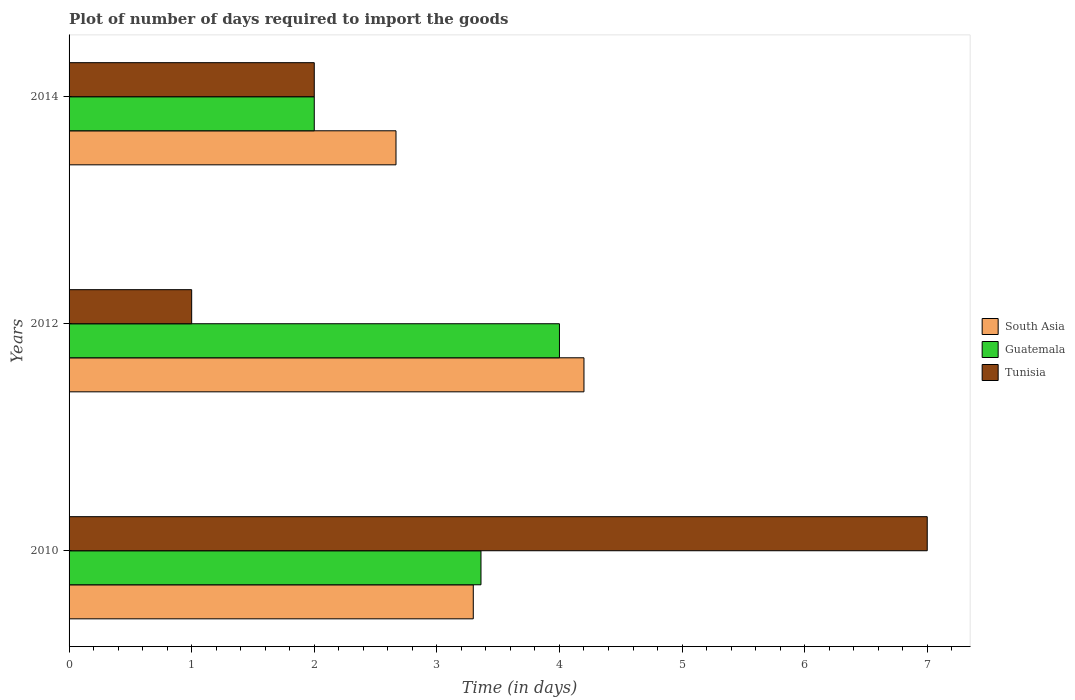How many groups of bars are there?
Make the answer very short. 3. Are the number of bars per tick equal to the number of legend labels?
Your response must be concise. Yes. Are the number of bars on each tick of the Y-axis equal?
Ensure brevity in your answer.  Yes. How many bars are there on the 1st tick from the top?
Make the answer very short. 3. How many bars are there on the 1st tick from the bottom?
Give a very brief answer. 3. What is the label of the 3rd group of bars from the top?
Ensure brevity in your answer.  2010. What is the time required to import goods in South Asia in 2014?
Keep it short and to the point. 2.67. Across all years, what is the maximum time required to import goods in Guatemala?
Your answer should be very brief. 4. Across all years, what is the minimum time required to import goods in Guatemala?
Provide a short and direct response. 2. In which year was the time required to import goods in South Asia minimum?
Provide a succinct answer. 2014. What is the total time required to import goods in Tunisia in the graph?
Your answer should be very brief. 10. What is the difference between the time required to import goods in Tunisia in 2010 and that in 2014?
Keep it short and to the point. 5. What is the difference between the time required to import goods in Guatemala in 2010 and the time required to import goods in Tunisia in 2012?
Give a very brief answer. 2.36. What is the average time required to import goods in Tunisia per year?
Provide a succinct answer. 3.33. In the year 2012, what is the difference between the time required to import goods in Tunisia and time required to import goods in South Asia?
Keep it short and to the point. -3.2. What is the ratio of the time required to import goods in Guatemala in 2010 to that in 2012?
Provide a succinct answer. 0.84. What is the difference between the highest and the second highest time required to import goods in Guatemala?
Provide a succinct answer. 0.64. In how many years, is the time required to import goods in Tunisia greater than the average time required to import goods in Tunisia taken over all years?
Your answer should be compact. 1. What does the 2nd bar from the top in 2014 represents?
Give a very brief answer. Guatemala. Are all the bars in the graph horizontal?
Your answer should be compact. Yes. How many years are there in the graph?
Keep it short and to the point. 3. What is the difference between two consecutive major ticks on the X-axis?
Provide a succinct answer. 1. Are the values on the major ticks of X-axis written in scientific E-notation?
Offer a very short reply. No. Does the graph contain grids?
Offer a terse response. No. Where does the legend appear in the graph?
Offer a terse response. Center right. How are the legend labels stacked?
Provide a short and direct response. Vertical. What is the title of the graph?
Provide a succinct answer. Plot of number of days required to import the goods. What is the label or title of the X-axis?
Give a very brief answer. Time (in days). What is the Time (in days) of South Asia in 2010?
Make the answer very short. 3.3. What is the Time (in days) of Guatemala in 2010?
Make the answer very short. 3.36. What is the Time (in days) in Guatemala in 2012?
Offer a terse response. 4. What is the Time (in days) of Tunisia in 2012?
Offer a very short reply. 1. What is the Time (in days) of South Asia in 2014?
Provide a short and direct response. 2.67. What is the Time (in days) of Guatemala in 2014?
Offer a terse response. 2. Across all years, what is the maximum Time (in days) in Guatemala?
Keep it short and to the point. 4. Across all years, what is the minimum Time (in days) of South Asia?
Provide a succinct answer. 2.67. Across all years, what is the minimum Time (in days) of Tunisia?
Make the answer very short. 1. What is the total Time (in days) in South Asia in the graph?
Offer a very short reply. 10.16. What is the total Time (in days) in Guatemala in the graph?
Ensure brevity in your answer.  9.36. What is the difference between the Time (in days) in South Asia in 2010 and that in 2012?
Make the answer very short. -0.9. What is the difference between the Time (in days) of Guatemala in 2010 and that in 2012?
Keep it short and to the point. -0.64. What is the difference between the Time (in days) of South Asia in 2010 and that in 2014?
Ensure brevity in your answer.  0.63. What is the difference between the Time (in days) of Guatemala in 2010 and that in 2014?
Provide a short and direct response. 1.36. What is the difference between the Time (in days) of Tunisia in 2010 and that in 2014?
Your response must be concise. 5. What is the difference between the Time (in days) of South Asia in 2012 and that in 2014?
Provide a succinct answer. 1.53. What is the difference between the Time (in days) in South Asia in 2010 and the Time (in days) in Guatemala in 2012?
Offer a terse response. -0.7. What is the difference between the Time (in days) of South Asia in 2010 and the Time (in days) of Tunisia in 2012?
Ensure brevity in your answer.  2.3. What is the difference between the Time (in days) in Guatemala in 2010 and the Time (in days) in Tunisia in 2012?
Keep it short and to the point. 2.36. What is the difference between the Time (in days) of South Asia in 2010 and the Time (in days) of Guatemala in 2014?
Ensure brevity in your answer.  1.3. What is the difference between the Time (in days) in South Asia in 2010 and the Time (in days) in Tunisia in 2014?
Provide a succinct answer. 1.3. What is the difference between the Time (in days) in Guatemala in 2010 and the Time (in days) in Tunisia in 2014?
Your answer should be compact. 1.36. What is the average Time (in days) in South Asia per year?
Keep it short and to the point. 3.39. What is the average Time (in days) in Guatemala per year?
Keep it short and to the point. 3.12. In the year 2010, what is the difference between the Time (in days) of South Asia and Time (in days) of Guatemala?
Provide a succinct answer. -0.06. In the year 2010, what is the difference between the Time (in days) of South Asia and Time (in days) of Tunisia?
Your response must be concise. -3.7. In the year 2010, what is the difference between the Time (in days) of Guatemala and Time (in days) of Tunisia?
Give a very brief answer. -3.64. In the year 2012, what is the difference between the Time (in days) of South Asia and Time (in days) of Tunisia?
Give a very brief answer. 3.2. In the year 2012, what is the difference between the Time (in days) of Guatemala and Time (in days) of Tunisia?
Give a very brief answer. 3. In the year 2014, what is the difference between the Time (in days) of South Asia and Time (in days) of Guatemala?
Your response must be concise. 0.67. What is the ratio of the Time (in days) of South Asia in 2010 to that in 2012?
Provide a short and direct response. 0.79. What is the ratio of the Time (in days) in Guatemala in 2010 to that in 2012?
Give a very brief answer. 0.84. What is the ratio of the Time (in days) of Tunisia in 2010 to that in 2012?
Provide a succinct answer. 7. What is the ratio of the Time (in days) of South Asia in 2010 to that in 2014?
Give a very brief answer. 1.24. What is the ratio of the Time (in days) of Guatemala in 2010 to that in 2014?
Provide a short and direct response. 1.68. What is the ratio of the Time (in days) of Tunisia in 2010 to that in 2014?
Your answer should be very brief. 3.5. What is the ratio of the Time (in days) of South Asia in 2012 to that in 2014?
Offer a very short reply. 1.57. What is the difference between the highest and the second highest Time (in days) of South Asia?
Your response must be concise. 0.9. What is the difference between the highest and the second highest Time (in days) in Guatemala?
Your answer should be compact. 0.64. What is the difference between the highest and the lowest Time (in days) of South Asia?
Your answer should be compact. 1.53. What is the difference between the highest and the lowest Time (in days) in Guatemala?
Offer a very short reply. 2. What is the difference between the highest and the lowest Time (in days) in Tunisia?
Ensure brevity in your answer.  6. 